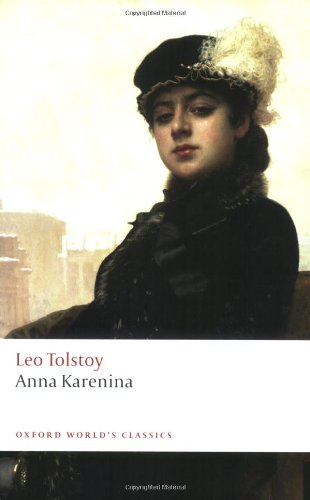What type of book is this? This book belongs to the 'Literature & Fiction' genre, specifically focusing on Russian literature. It explores complex themes of love, family, and societal norms in 19th-century Russia. 